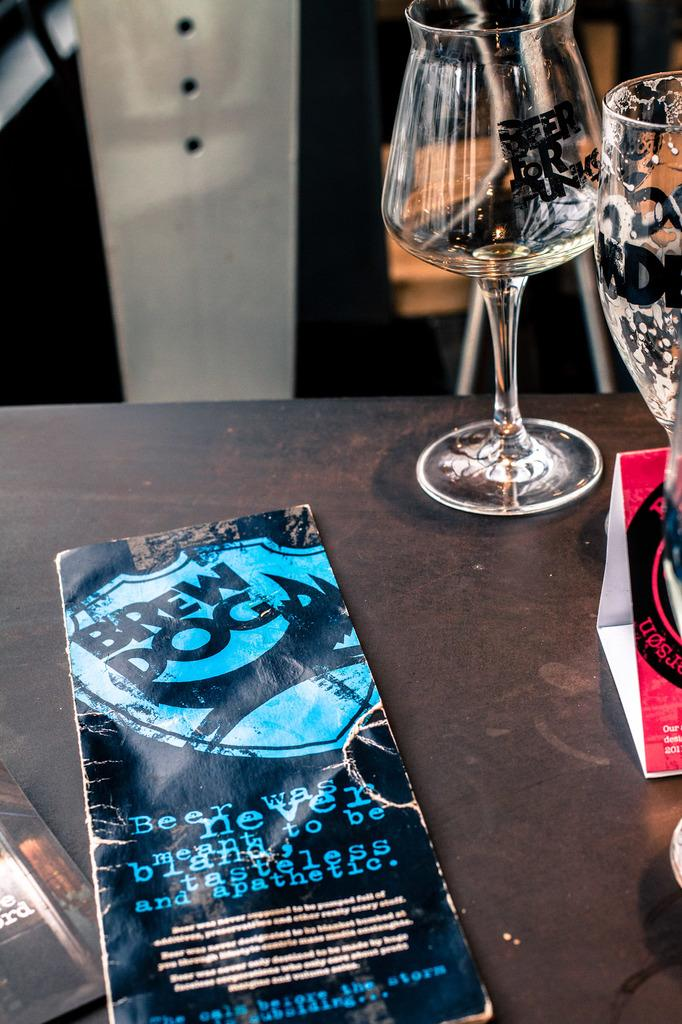What is the primary location of the objects in the image? The objects are on a table in the image. Can you describe any objects that are visible behind the table? Unfortunately, the provided facts do not specify any objects visible behind the table. What type of cart is used to transport the copper in the image? There is no cart or copper present in the image. 